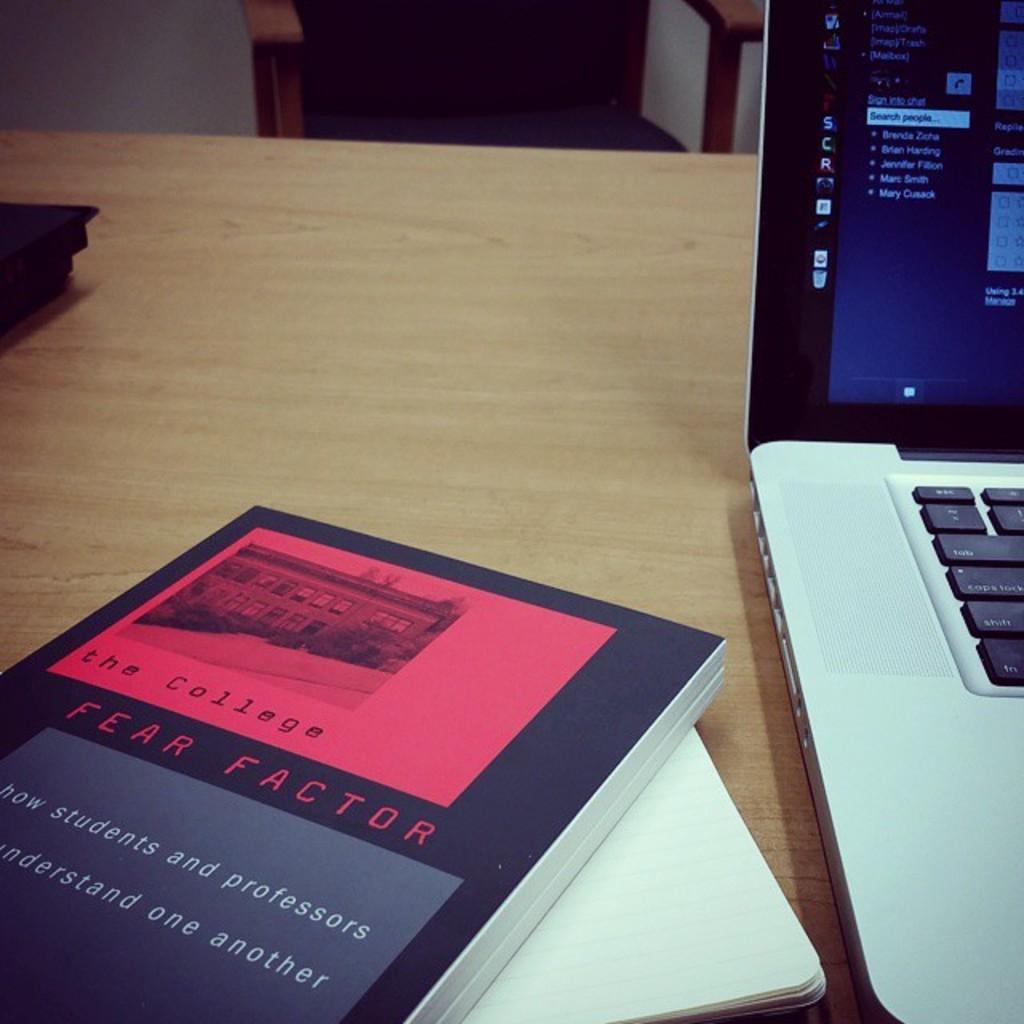Are both students and professors mentioned on the cover?
Your answer should be very brief. Yes. 